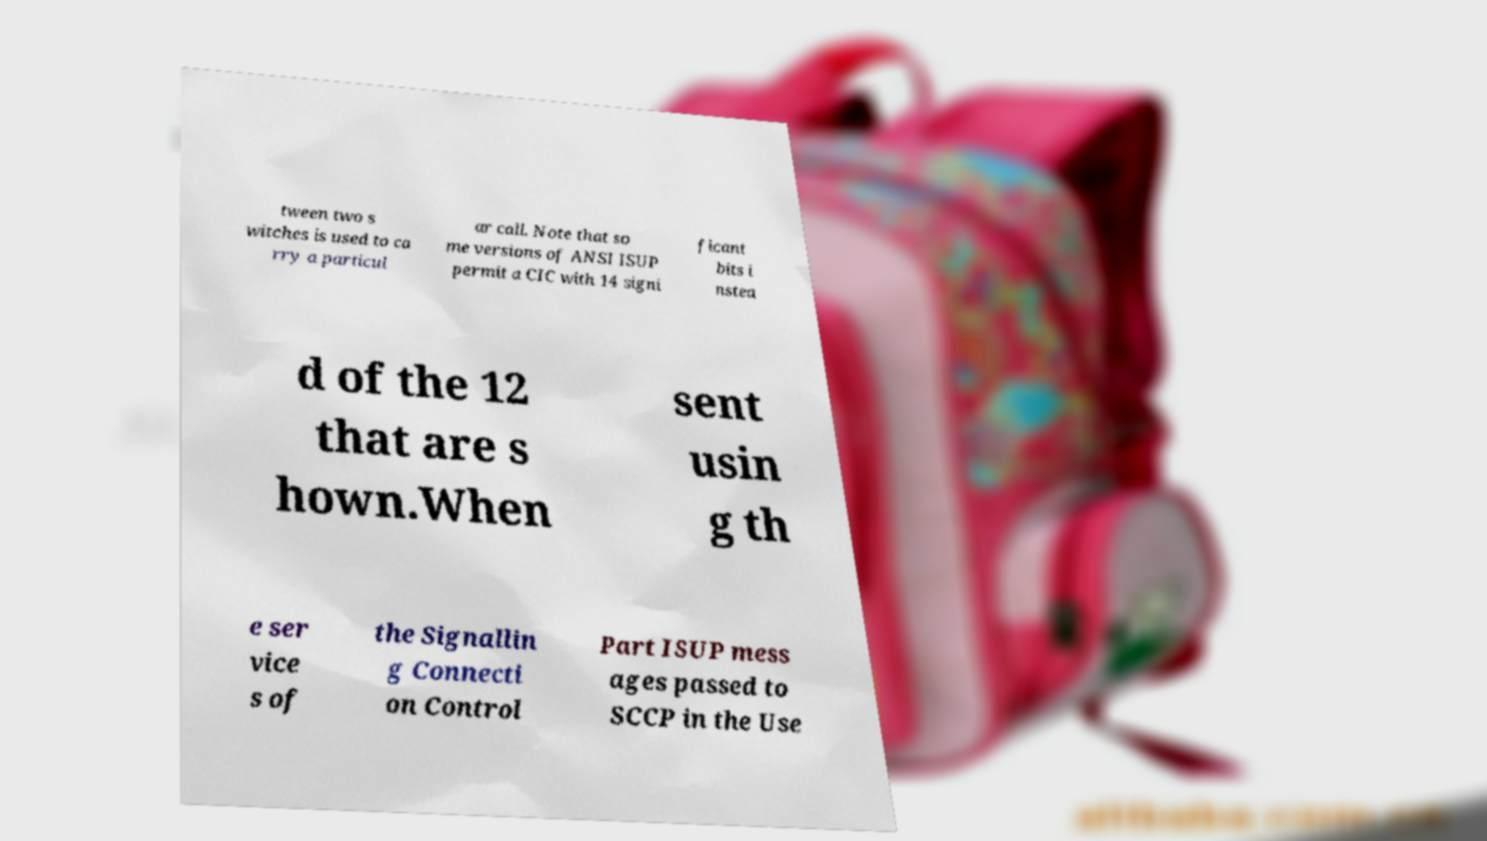Can you accurately transcribe the text from the provided image for me? tween two s witches is used to ca rry a particul ar call. Note that so me versions of ANSI ISUP permit a CIC with 14 signi ficant bits i nstea d of the 12 that are s hown.When sent usin g th e ser vice s of the Signallin g Connecti on Control Part ISUP mess ages passed to SCCP in the Use 